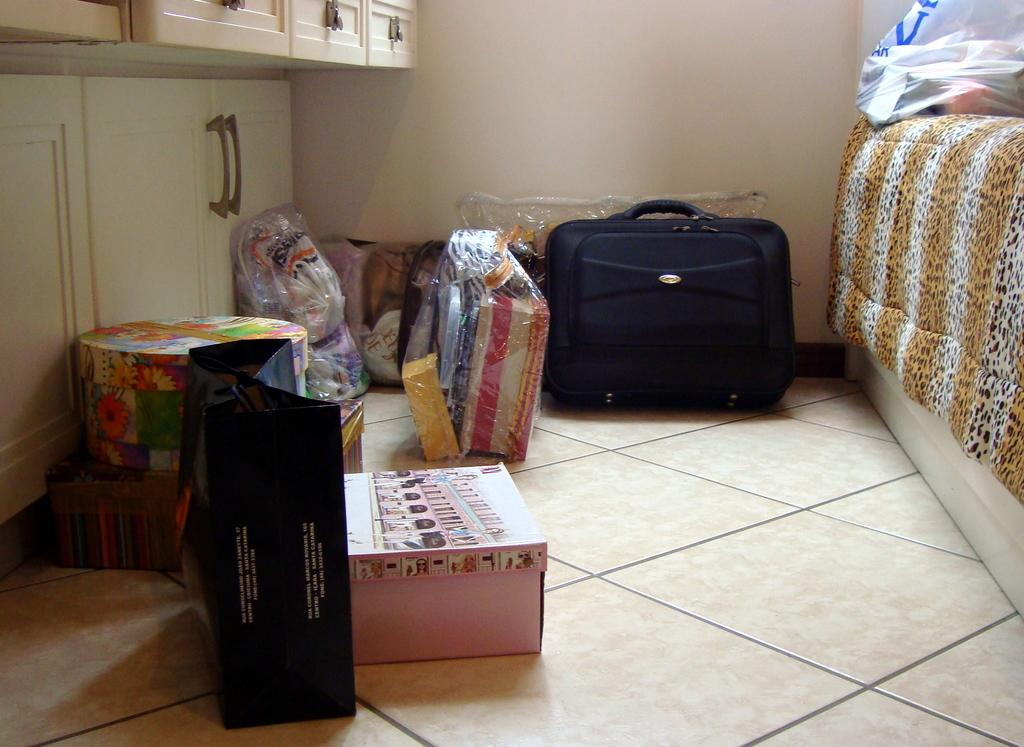What object can be seen in the image that is commonly used for carrying belongings? There is a suitcase in the image. What object in the image might be used to cover or protect something? There is a cover in the image. What object in the image might be used for storage? There is a box in the image. What object in the image might be used for cleaning or wiping? There is a cloth in the image. What can be seen in the background of the image? There is a wall in the background of the image. What object can be seen on the left side of the image? There is a cupboard on the left side of the image. How many beads are visible on the wall in the image? There are no beads visible on the wall in the image. What type of toothbrush is being used by the parent in the image? There is no parent or toothbrush present in the image. 